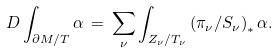Convert formula to latex. <formula><loc_0><loc_0><loc_500><loc_500>\ D \int _ { \partial M / T } \alpha \, = \, \sum _ { \nu } \int _ { Z _ { \nu } / T _ { \nu } } \left ( \pi _ { \nu } / S _ { \nu } \right ) _ { * } \alpha .</formula> 